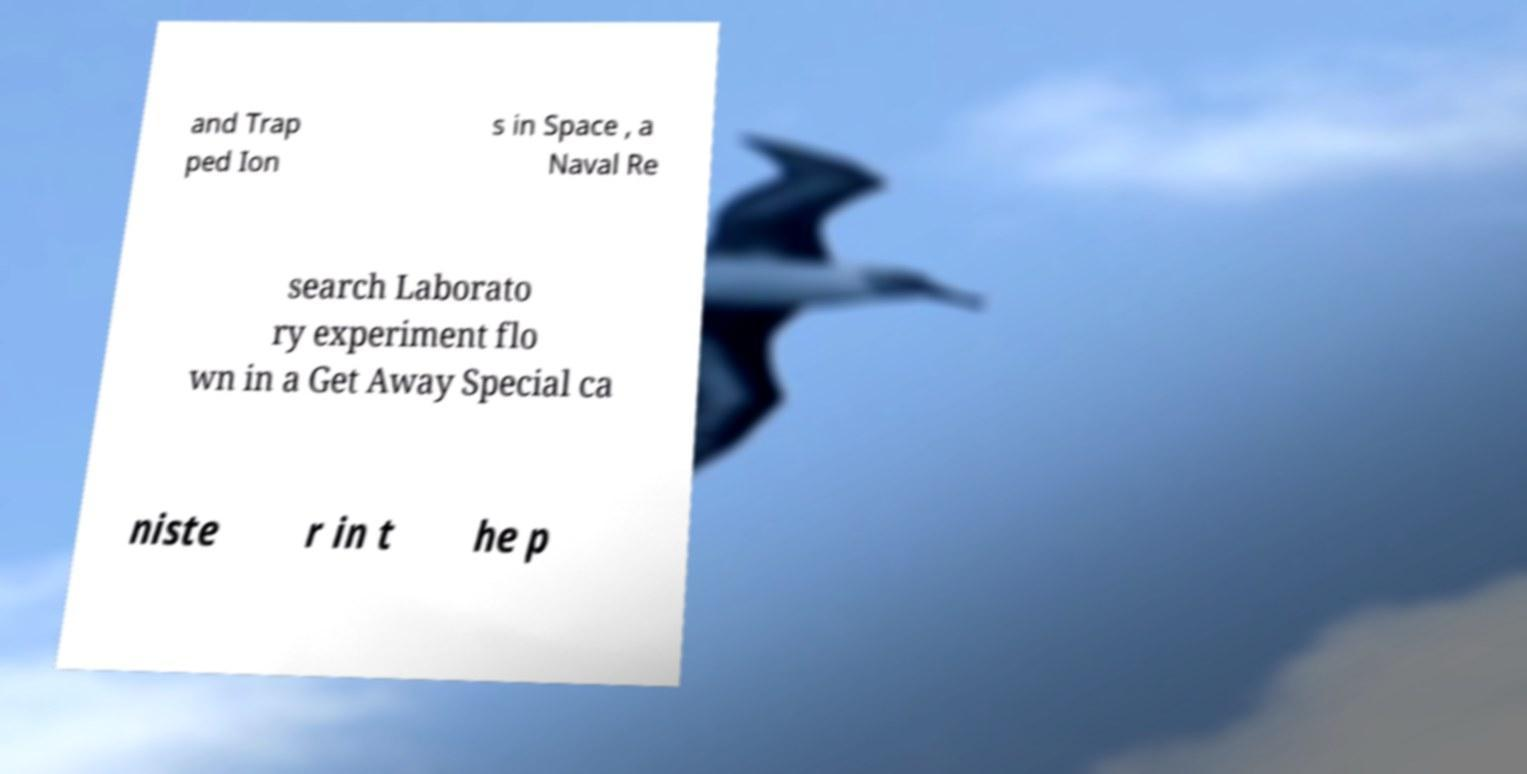There's text embedded in this image that I need extracted. Can you transcribe it verbatim? and Trap ped Ion s in Space , a Naval Re search Laborato ry experiment flo wn in a Get Away Special ca niste r in t he p 